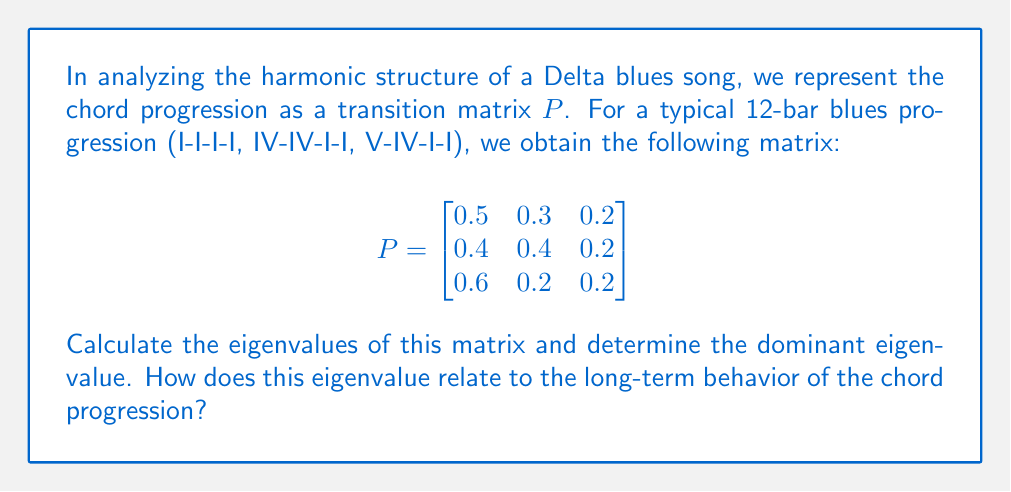Could you help me with this problem? To analyze the harmonic structure using eigenvalue decomposition, we follow these steps:

1) First, we need to find the characteristic equation of the matrix $P$:
   $det(P - \lambda I) = 0$

2) Expand the determinant:
   $$\begin{vmatrix}
   0.5-\lambda & 0.3 & 0.2 \\
   0.4 & 0.4-\lambda & 0.2 \\
   0.6 & 0.2 & 0.2-\lambda
   \end{vmatrix} = 0$$

3) Solve the resulting cubic equation:
   $-\lambda^3 + 1.1\lambda^2 - 0.07\lambda - 0.024 = 0$

4) The roots of this equation are the eigenvalues. Using a numerical method or a calculator, we find:
   $\lambda_1 \approx 1$
   $\lambda_2 \approx 0.0781$
   $\lambda_3 \approx 0.0219$

5) The dominant eigenvalue is the largest in magnitude, which is $\lambda_1 \approx 1$.

6) In the context of a Markov chain (which this chord progression represents), the dominant eigenvalue being 1 indicates that the chain is regular and has a unique stationary distribution.

7) This means that, in the long run, the frequency of each chord in the progression will stabilize, regardless of the starting point. This stability reflects the cyclic nature of the 12-bar blues form, where the progression repeats consistently.

8) The corresponding eigenvector to this dominant eigenvalue would represent the long-term probability distribution of the chords, giving insight into which chords are most prominent in the overall harmonic structure of Delta blues.
Answer: Dominant eigenvalue ≈ 1, indicating a stable, repeating harmonic structure. 